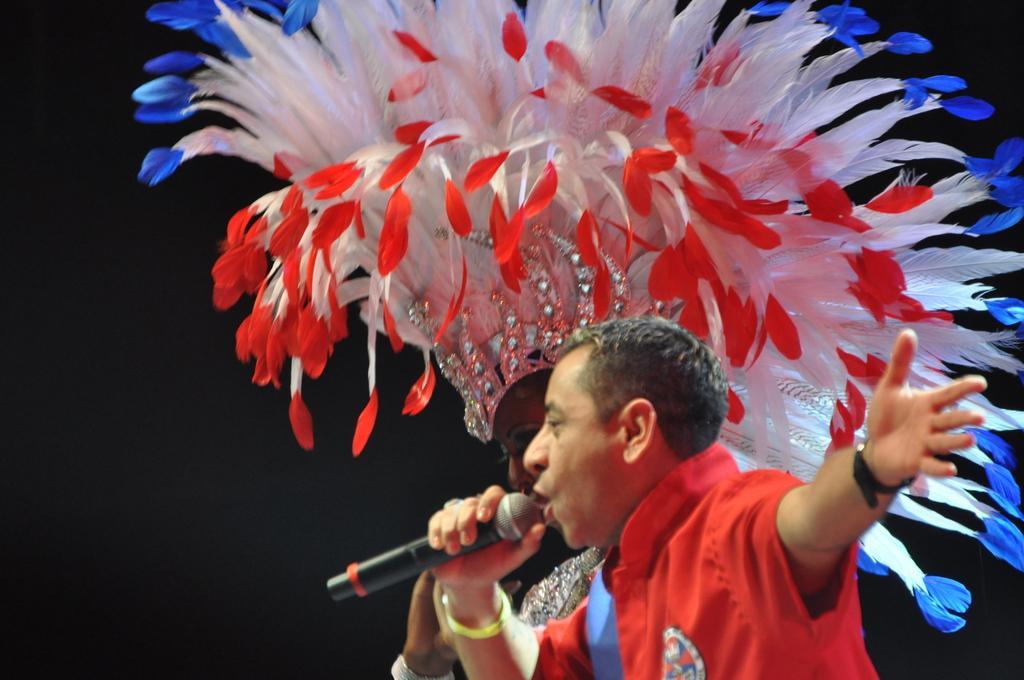Describe this image in one or two sentences. In this picture I can see a man and a woman in front and I see that this man is holding a mic and this woman is wearing a costume and I see that it is dark in the background. 